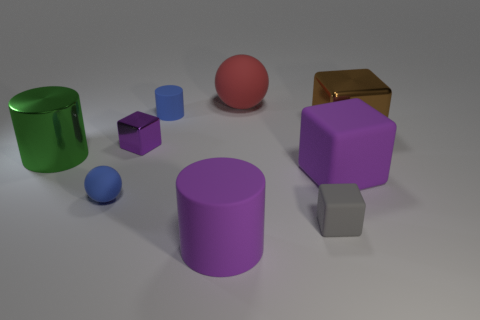Subtract 1 blocks. How many blocks are left? 3 Subtract all gray cubes. Subtract all yellow spheres. How many cubes are left? 3 Subtract all cylinders. How many objects are left? 6 Add 5 blue rubber cylinders. How many blue rubber cylinders exist? 6 Subtract 2 purple blocks. How many objects are left? 7 Subtract all red objects. Subtract all metallic cubes. How many objects are left? 6 Add 7 small shiny things. How many small shiny things are left? 8 